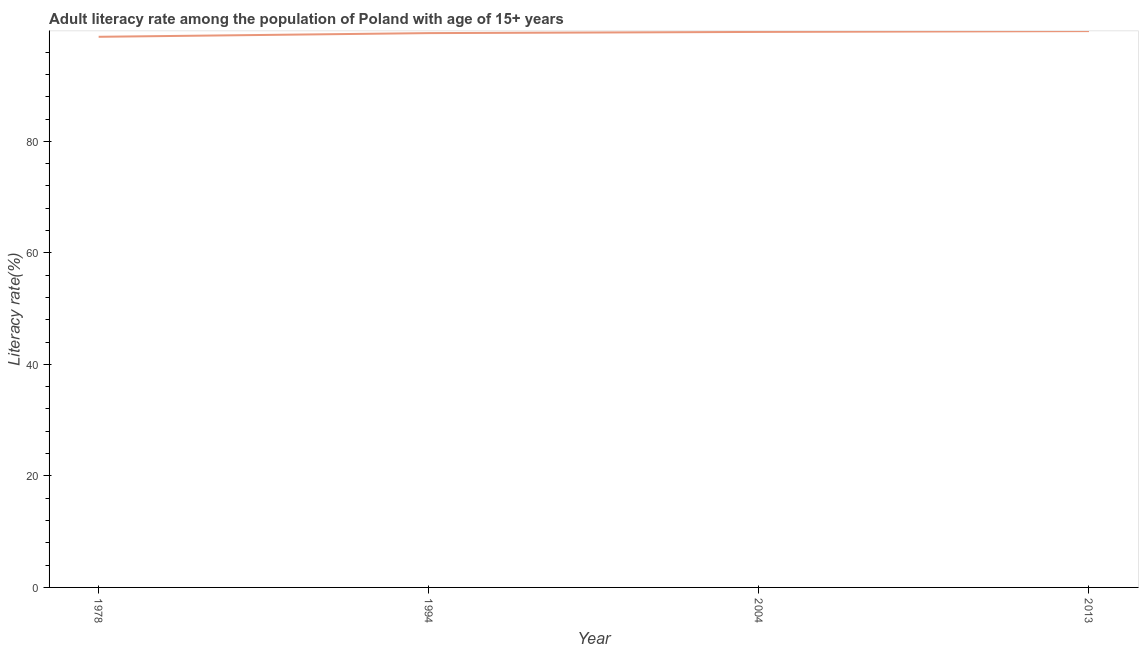What is the adult literacy rate in 1994?
Provide a short and direct response. 99.4. Across all years, what is the maximum adult literacy rate?
Ensure brevity in your answer.  99.76. Across all years, what is the minimum adult literacy rate?
Give a very brief answer. 98.74. In which year was the adult literacy rate minimum?
Offer a very short reply. 1978. What is the sum of the adult literacy rate?
Ensure brevity in your answer.  397.53. What is the difference between the adult literacy rate in 1994 and 2004?
Offer a very short reply. -0.22. What is the average adult literacy rate per year?
Offer a terse response. 99.38. What is the median adult literacy rate?
Your answer should be very brief. 99.51. What is the ratio of the adult literacy rate in 1978 to that in 1994?
Provide a short and direct response. 0.99. Is the adult literacy rate in 1978 less than that in 2004?
Keep it short and to the point. Yes. Is the difference between the adult literacy rate in 1978 and 2004 greater than the difference between any two years?
Provide a short and direct response. No. What is the difference between the highest and the second highest adult literacy rate?
Your answer should be compact. 0.14. What is the difference between the highest and the lowest adult literacy rate?
Your response must be concise. 1.02. Does the adult literacy rate monotonically increase over the years?
Your answer should be very brief. Yes. What is the difference between two consecutive major ticks on the Y-axis?
Make the answer very short. 20. What is the title of the graph?
Provide a short and direct response. Adult literacy rate among the population of Poland with age of 15+ years. What is the label or title of the Y-axis?
Your answer should be compact. Literacy rate(%). What is the Literacy rate(%) of 1978?
Your response must be concise. 98.74. What is the Literacy rate(%) in 1994?
Keep it short and to the point. 99.4. What is the Literacy rate(%) in 2004?
Your answer should be compact. 99.62. What is the Literacy rate(%) of 2013?
Offer a terse response. 99.76. What is the difference between the Literacy rate(%) in 1978 and 1994?
Make the answer very short. -0.66. What is the difference between the Literacy rate(%) in 1978 and 2004?
Provide a succinct answer. -0.88. What is the difference between the Literacy rate(%) in 1978 and 2013?
Offer a very short reply. -1.02. What is the difference between the Literacy rate(%) in 1994 and 2004?
Provide a succinct answer. -0.22. What is the difference between the Literacy rate(%) in 1994 and 2013?
Offer a terse response. -0.36. What is the difference between the Literacy rate(%) in 2004 and 2013?
Your response must be concise. -0.14. What is the ratio of the Literacy rate(%) in 1994 to that in 2013?
Your response must be concise. 1. 